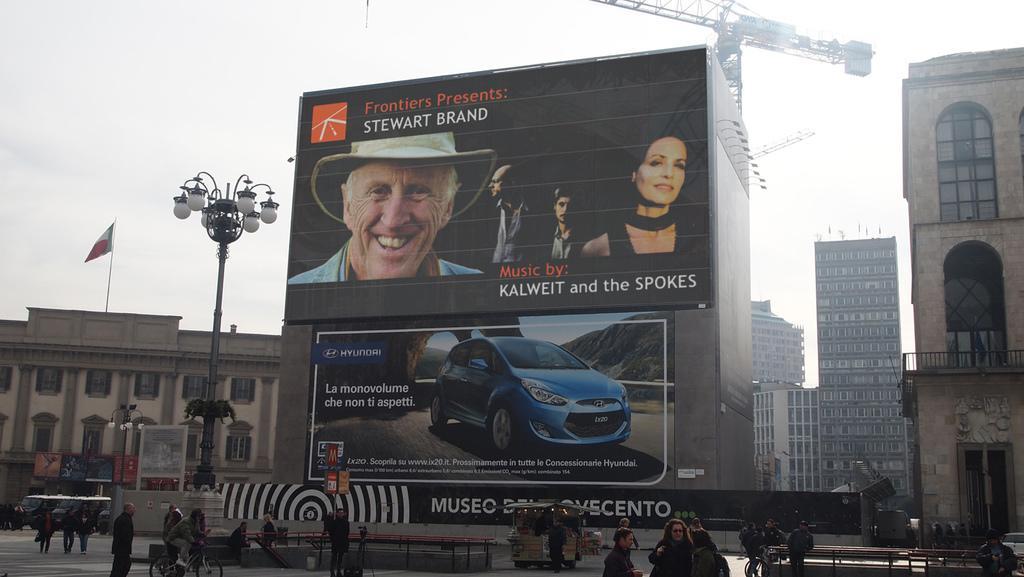Can you describe this image briefly? In this image we can see so many buildings, there are some windows, lights, poles, vehicles, people, grille and boards with text and images, also we can see a flag and in the background, we can see the sky. 